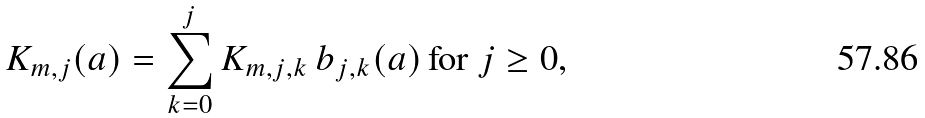<formula> <loc_0><loc_0><loc_500><loc_500>K _ { m , j } ( { a } ) = \sum _ { k = 0 } ^ { j } K _ { m , j , k } \, b _ { j , k } ( { a } ) \, \text {for $j\geq 0$,}</formula> 